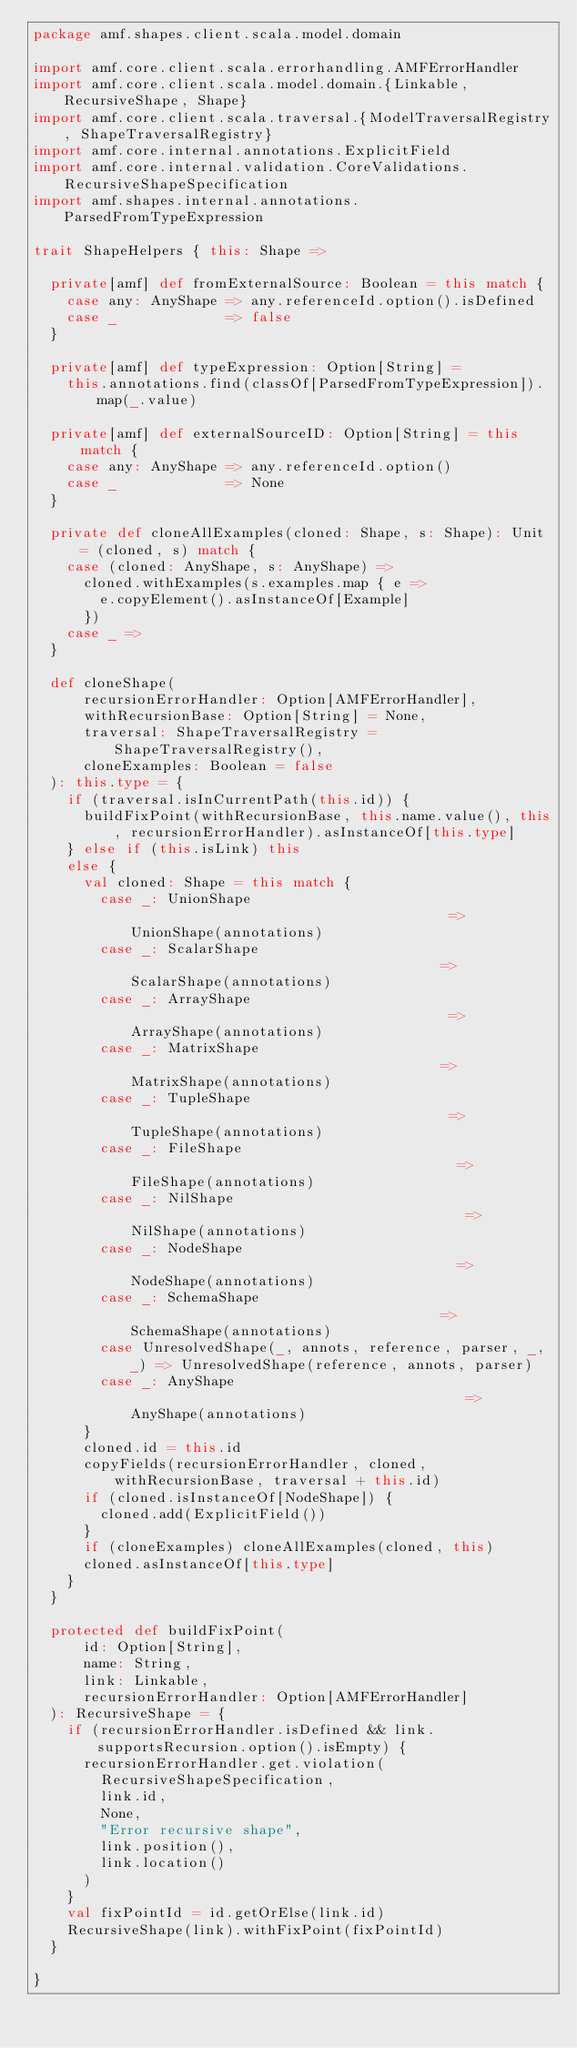Convert code to text. <code><loc_0><loc_0><loc_500><loc_500><_Scala_>package amf.shapes.client.scala.model.domain

import amf.core.client.scala.errorhandling.AMFErrorHandler
import amf.core.client.scala.model.domain.{Linkable, RecursiveShape, Shape}
import amf.core.client.scala.traversal.{ModelTraversalRegistry, ShapeTraversalRegistry}
import amf.core.internal.annotations.ExplicitField
import amf.core.internal.validation.CoreValidations.RecursiveShapeSpecification
import amf.shapes.internal.annotations.ParsedFromTypeExpression

trait ShapeHelpers { this: Shape =>

  private[amf] def fromExternalSource: Boolean = this match {
    case any: AnyShape => any.referenceId.option().isDefined
    case _             => false
  }

  private[amf] def typeExpression: Option[String] =
    this.annotations.find(classOf[ParsedFromTypeExpression]).map(_.value)

  private[amf] def externalSourceID: Option[String] = this match {
    case any: AnyShape => any.referenceId.option()
    case _             => None
  }

  private def cloneAllExamples(cloned: Shape, s: Shape): Unit = (cloned, s) match {
    case (cloned: AnyShape, s: AnyShape) =>
      cloned.withExamples(s.examples.map { e =>
        e.copyElement().asInstanceOf[Example]
      })
    case _ =>
  }

  def cloneShape(
      recursionErrorHandler: Option[AMFErrorHandler],
      withRecursionBase: Option[String] = None,
      traversal: ShapeTraversalRegistry = ShapeTraversalRegistry(),
      cloneExamples: Boolean = false
  ): this.type = {
    if (traversal.isInCurrentPath(this.id)) {
      buildFixPoint(withRecursionBase, this.name.value(), this, recursionErrorHandler).asInstanceOf[this.type]
    } else if (this.isLink) this
    else {
      val cloned: Shape = this match {
        case _: UnionShape                                       => UnionShape(annotations)
        case _: ScalarShape                                      => ScalarShape(annotations)
        case _: ArrayShape                                       => ArrayShape(annotations)
        case _: MatrixShape                                      => MatrixShape(annotations)
        case _: TupleShape                                       => TupleShape(annotations)
        case _: FileShape                                        => FileShape(annotations)
        case _: NilShape                                         => NilShape(annotations)
        case _: NodeShape                                        => NodeShape(annotations)
        case _: SchemaShape                                      => SchemaShape(annotations)
        case UnresolvedShape(_, annots, reference, parser, _, _) => UnresolvedShape(reference, annots, parser)
        case _: AnyShape                                         => AnyShape(annotations)
      }
      cloned.id = this.id
      copyFields(recursionErrorHandler, cloned, withRecursionBase, traversal + this.id)
      if (cloned.isInstanceOf[NodeShape]) {
        cloned.add(ExplicitField())
      }
      if (cloneExamples) cloneAllExamples(cloned, this)
      cloned.asInstanceOf[this.type]
    }
  }

  protected def buildFixPoint(
      id: Option[String],
      name: String,
      link: Linkable,
      recursionErrorHandler: Option[AMFErrorHandler]
  ): RecursiveShape = {
    if (recursionErrorHandler.isDefined && link.supportsRecursion.option().isEmpty) {
      recursionErrorHandler.get.violation(
        RecursiveShapeSpecification,
        link.id,
        None,
        "Error recursive shape",
        link.position(),
        link.location()
      )
    }
    val fixPointId = id.getOrElse(link.id)
    RecursiveShape(link).withFixPoint(fixPointId)
  }

}
</code> 